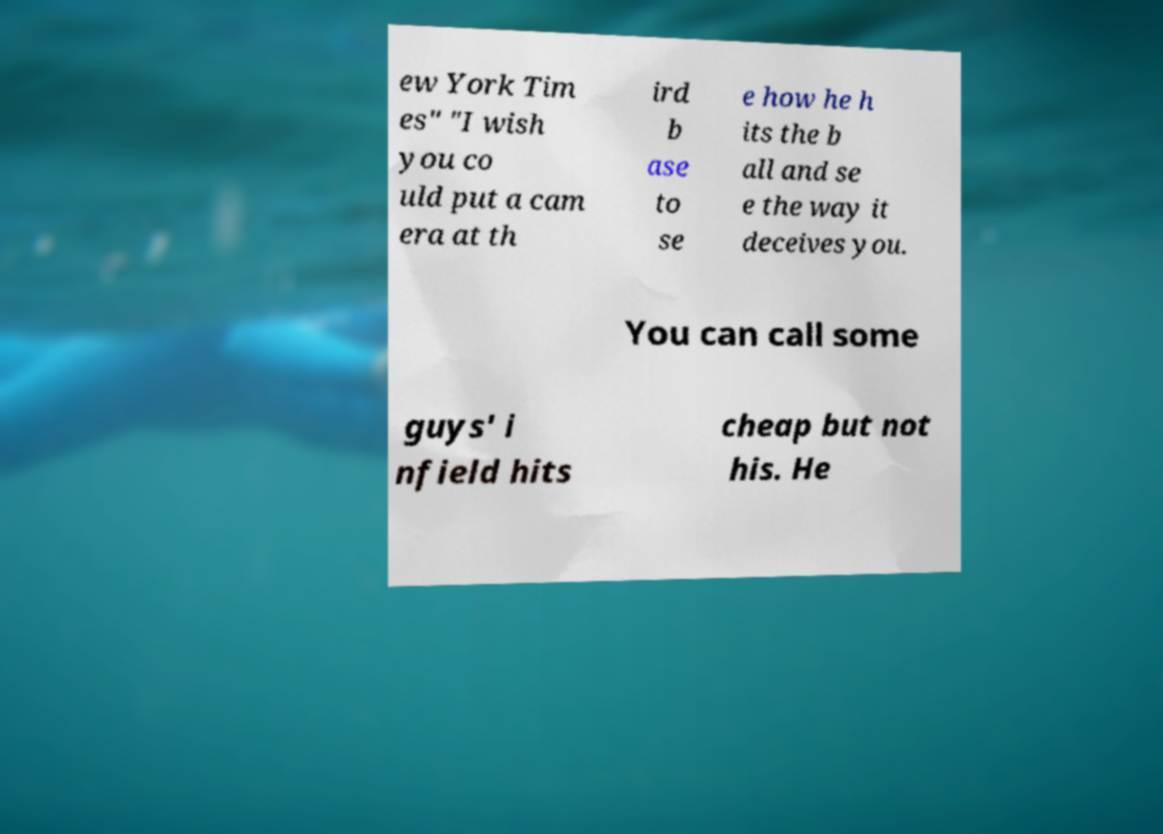For documentation purposes, I need the text within this image transcribed. Could you provide that? ew York Tim es" "I wish you co uld put a cam era at th ird b ase to se e how he h its the b all and se e the way it deceives you. You can call some guys' i nfield hits cheap but not his. He 